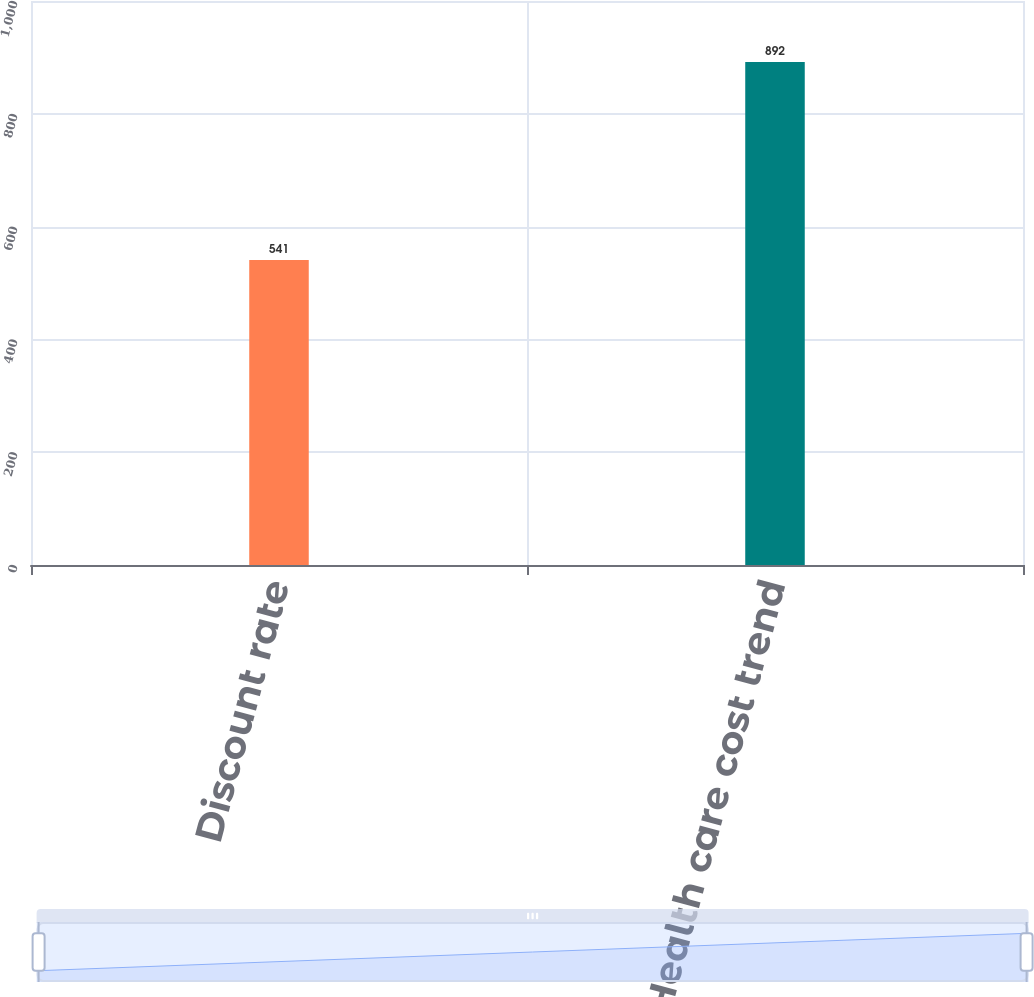Convert chart. <chart><loc_0><loc_0><loc_500><loc_500><bar_chart><fcel>Discount rate<fcel>Health care cost trend<nl><fcel>541<fcel>892<nl></chart> 